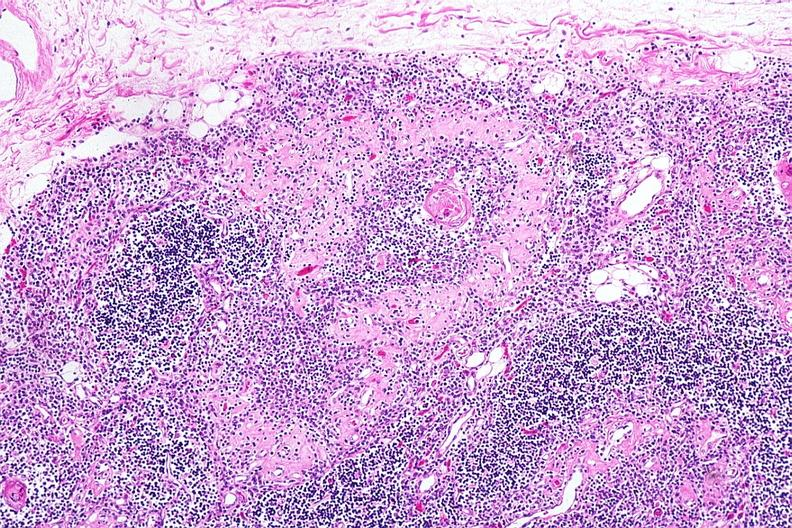what does this image show?
Answer the question using a single word or phrase. Hassalls corpuscle with fibrosis in periphery of surrounding lymphoid follicle lesion 